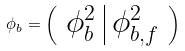Convert formula to latex. <formula><loc_0><loc_0><loc_500><loc_500>\phi _ { b } = \left ( \begin{array} { c | c } \phi ^ { 2 } _ { b } & \phi ^ { 2 } _ { b , f } \\ \end{array} \right )</formula> 